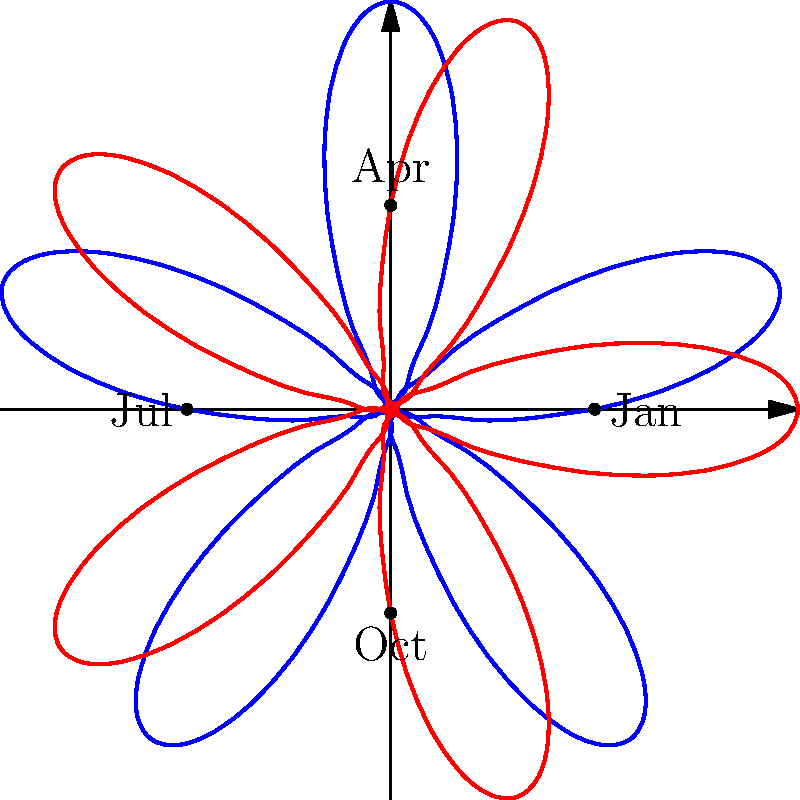As the curator of your family-owned museum, you're analyzing visitor demographics throughout the year. The polar rose diagram above represents two different visitor groups. Which month shows the highest discrepancy between the two groups, and what could this suggest about your museum's audience? To answer this question, we need to analyze the polar rose diagram step-by-step:

1. The diagram shows two polar roses: one in blue and one in red.
2. Each rose represents a different visitor group throughout the year.
3. The distance from the center in any direction represents the relative number of visitors for that group at that time of year.
4. The diagram is divided into four quadrants, representing the four seasons (Jan, Apr, Jul, Oct).
5. To find the month with the highest discrepancy, we need to identify where the difference between the blue and red curves is greatest.
6. Observing the diagram, we can see that the largest gap between the two curves occurs in the bottom-right quadrant, corresponding to the period between October and January.
7. The blue curve extends much further than the red curve in this area, particularly around November-December.
8. This suggests that one visitor group (represented by the blue curve) has a significantly higher attendance during the late fall/early winter months compared to the other group (red curve).

Given your role as a curator focusing on local artists, this discrepancy could suggest:
- Your museum might be hosting special exhibitions or events featuring local artists during the holiday season, attracting more of one demographic.
- There could be a difference in how various visitor groups respond to winter-themed or end-of-year exhibitions.
- The blue group might represent local visitors who are more likely to visit during colder months, while the red group could be tourists who visit less in winter.

Understanding this pattern can help you tailor your curation and marketing strategies to better engage both groups throughout the year, particularly focusing on how to attract the underrepresented group (red) during the winter months.
Answer: November-December; suggests seasonal preferences or targeted winter programming appealing more to one demographic. 